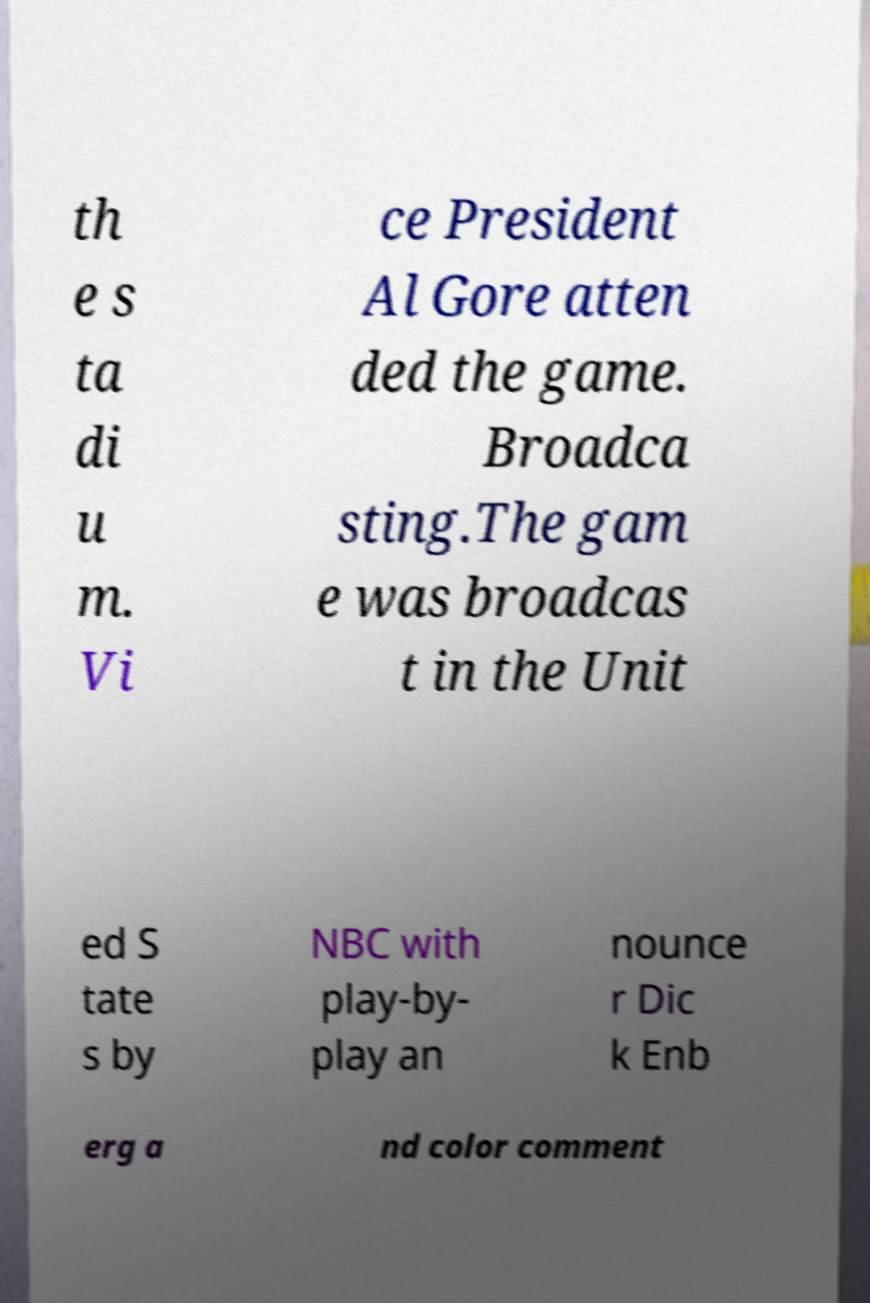Please read and relay the text visible in this image. What does it say? th e s ta di u m. Vi ce President Al Gore atten ded the game. Broadca sting.The gam e was broadcas t in the Unit ed S tate s by NBC with play-by- play an nounce r Dic k Enb erg a nd color comment 